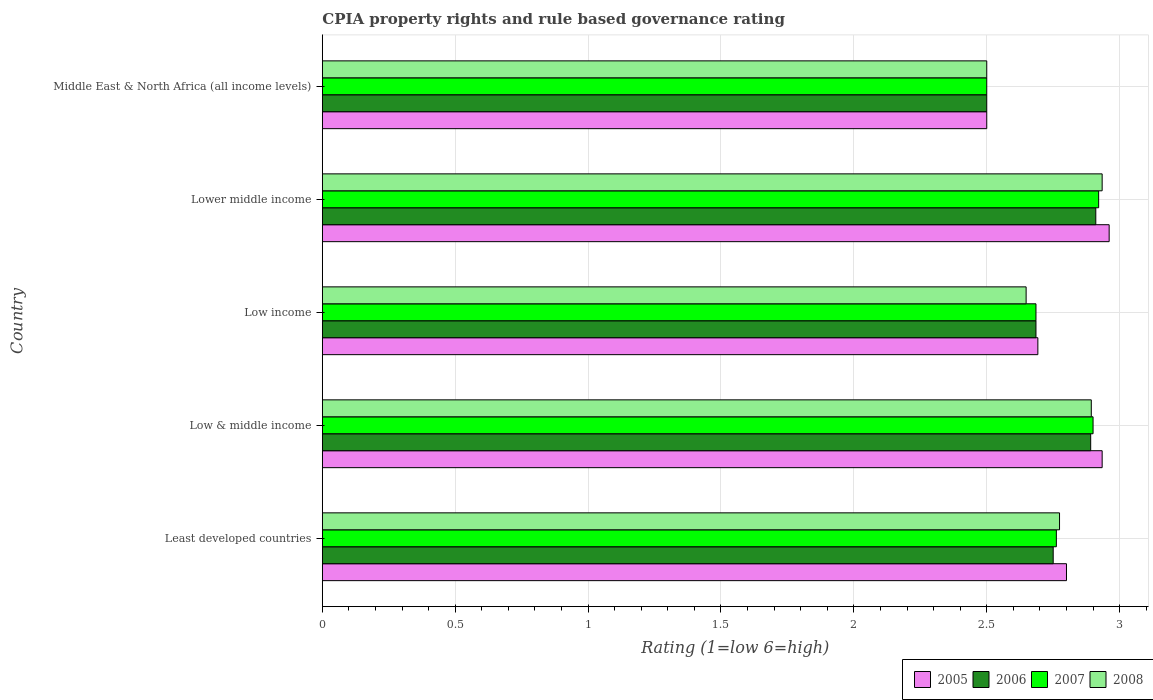How many different coloured bars are there?
Offer a terse response. 4. Are the number of bars per tick equal to the number of legend labels?
Make the answer very short. Yes. How many bars are there on the 2nd tick from the bottom?
Offer a terse response. 4. What is the CPIA rating in 2007 in Low income?
Your answer should be very brief. 2.69. Across all countries, what is the maximum CPIA rating in 2006?
Ensure brevity in your answer.  2.91. In which country was the CPIA rating in 2007 maximum?
Your answer should be compact. Lower middle income. In which country was the CPIA rating in 2006 minimum?
Your answer should be very brief. Middle East & North Africa (all income levels). What is the total CPIA rating in 2008 in the graph?
Provide a succinct answer. 13.75. What is the difference between the CPIA rating in 2008 in Low income and that in Middle East & North Africa (all income levels)?
Keep it short and to the point. 0.15. What is the difference between the CPIA rating in 2005 in Lower middle income and the CPIA rating in 2008 in Middle East & North Africa (all income levels)?
Provide a short and direct response. 0.46. What is the average CPIA rating in 2005 per country?
Offer a terse response. 2.78. What is the ratio of the CPIA rating in 2005 in Least developed countries to that in Lower middle income?
Your answer should be compact. 0.95. Is the CPIA rating in 2008 in Least developed countries less than that in Low income?
Offer a very short reply. No. Is the difference between the CPIA rating in 2007 in Least developed countries and Middle East & North Africa (all income levels) greater than the difference between the CPIA rating in 2008 in Least developed countries and Middle East & North Africa (all income levels)?
Give a very brief answer. No. What is the difference between the highest and the second highest CPIA rating in 2005?
Provide a short and direct response. 0.03. What is the difference between the highest and the lowest CPIA rating in 2007?
Ensure brevity in your answer.  0.42. In how many countries, is the CPIA rating in 2006 greater than the average CPIA rating in 2006 taken over all countries?
Keep it short and to the point. 3. Is it the case that in every country, the sum of the CPIA rating in 2008 and CPIA rating in 2005 is greater than the sum of CPIA rating in 2006 and CPIA rating in 2007?
Offer a very short reply. No. What does the 3rd bar from the bottom in Lower middle income represents?
Ensure brevity in your answer.  2007. Are all the bars in the graph horizontal?
Your answer should be very brief. Yes. How many countries are there in the graph?
Your answer should be compact. 5. What is the difference between two consecutive major ticks on the X-axis?
Provide a short and direct response. 0.5. Are the values on the major ticks of X-axis written in scientific E-notation?
Offer a very short reply. No. Where does the legend appear in the graph?
Your answer should be very brief. Bottom right. How many legend labels are there?
Offer a very short reply. 4. What is the title of the graph?
Make the answer very short. CPIA property rights and rule based governance rating. Does "1969" appear as one of the legend labels in the graph?
Your answer should be compact. No. What is the label or title of the Y-axis?
Offer a terse response. Country. What is the Rating (1=low 6=high) in 2005 in Least developed countries?
Offer a terse response. 2.8. What is the Rating (1=low 6=high) in 2006 in Least developed countries?
Provide a short and direct response. 2.75. What is the Rating (1=low 6=high) in 2007 in Least developed countries?
Offer a very short reply. 2.76. What is the Rating (1=low 6=high) of 2008 in Least developed countries?
Provide a short and direct response. 2.77. What is the Rating (1=low 6=high) in 2005 in Low & middle income?
Give a very brief answer. 2.93. What is the Rating (1=low 6=high) of 2006 in Low & middle income?
Provide a short and direct response. 2.89. What is the Rating (1=low 6=high) of 2008 in Low & middle income?
Your answer should be very brief. 2.89. What is the Rating (1=low 6=high) of 2005 in Low income?
Give a very brief answer. 2.69. What is the Rating (1=low 6=high) in 2006 in Low income?
Keep it short and to the point. 2.69. What is the Rating (1=low 6=high) in 2007 in Low income?
Keep it short and to the point. 2.69. What is the Rating (1=low 6=high) in 2008 in Low income?
Your answer should be compact. 2.65. What is the Rating (1=low 6=high) in 2005 in Lower middle income?
Keep it short and to the point. 2.96. What is the Rating (1=low 6=high) in 2006 in Lower middle income?
Keep it short and to the point. 2.91. What is the Rating (1=low 6=high) of 2007 in Lower middle income?
Your answer should be compact. 2.92. What is the Rating (1=low 6=high) of 2008 in Lower middle income?
Offer a terse response. 2.93. What is the Rating (1=low 6=high) in 2005 in Middle East & North Africa (all income levels)?
Make the answer very short. 2.5. What is the Rating (1=low 6=high) of 2007 in Middle East & North Africa (all income levels)?
Give a very brief answer. 2.5. What is the Rating (1=low 6=high) in 2008 in Middle East & North Africa (all income levels)?
Offer a very short reply. 2.5. Across all countries, what is the maximum Rating (1=low 6=high) of 2005?
Ensure brevity in your answer.  2.96. Across all countries, what is the maximum Rating (1=low 6=high) of 2006?
Make the answer very short. 2.91. Across all countries, what is the maximum Rating (1=low 6=high) in 2007?
Provide a succinct answer. 2.92. Across all countries, what is the maximum Rating (1=low 6=high) of 2008?
Offer a very short reply. 2.93. Across all countries, what is the minimum Rating (1=low 6=high) in 2005?
Offer a very short reply. 2.5. Across all countries, what is the minimum Rating (1=low 6=high) in 2006?
Provide a succinct answer. 2.5. Across all countries, what is the minimum Rating (1=low 6=high) in 2008?
Your response must be concise. 2.5. What is the total Rating (1=low 6=high) in 2005 in the graph?
Offer a terse response. 13.89. What is the total Rating (1=low 6=high) of 2006 in the graph?
Make the answer very short. 13.74. What is the total Rating (1=low 6=high) in 2007 in the graph?
Provide a short and direct response. 13.77. What is the total Rating (1=low 6=high) of 2008 in the graph?
Your response must be concise. 13.75. What is the difference between the Rating (1=low 6=high) in 2005 in Least developed countries and that in Low & middle income?
Make the answer very short. -0.13. What is the difference between the Rating (1=low 6=high) of 2006 in Least developed countries and that in Low & middle income?
Give a very brief answer. -0.14. What is the difference between the Rating (1=low 6=high) in 2007 in Least developed countries and that in Low & middle income?
Provide a short and direct response. -0.14. What is the difference between the Rating (1=low 6=high) in 2008 in Least developed countries and that in Low & middle income?
Offer a very short reply. -0.12. What is the difference between the Rating (1=low 6=high) of 2005 in Least developed countries and that in Low income?
Make the answer very short. 0.11. What is the difference between the Rating (1=low 6=high) in 2006 in Least developed countries and that in Low income?
Provide a succinct answer. 0.06. What is the difference between the Rating (1=low 6=high) in 2007 in Least developed countries and that in Low income?
Give a very brief answer. 0.08. What is the difference between the Rating (1=low 6=high) in 2008 in Least developed countries and that in Low income?
Ensure brevity in your answer.  0.13. What is the difference between the Rating (1=low 6=high) in 2005 in Least developed countries and that in Lower middle income?
Give a very brief answer. -0.16. What is the difference between the Rating (1=low 6=high) in 2006 in Least developed countries and that in Lower middle income?
Make the answer very short. -0.16. What is the difference between the Rating (1=low 6=high) of 2007 in Least developed countries and that in Lower middle income?
Give a very brief answer. -0.16. What is the difference between the Rating (1=low 6=high) in 2008 in Least developed countries and that in Lower middle income?
Offer a terse response. -0.16. What is the difference between the Rating (1=low 6=high) in 2006 in Least developed countries and that in Middle East & North Africa (all income levels)?
Your answer should be very brief. 0.25. What is the difference between the Rating (1=low 6=high) of 2007 in Least developed countries and that in Middle East & North Africa (all income levels)?
Your response must be concise. 0.26. What is the difference between the Rating (1=low 6=high) in 2008 in Least developed countries and that in Middle East & North Africa (all income levels)?
Make the answer very short. 0.27. What is the difference between the Rating (1=low 6=high) of 2005 in Low & middle income and that in Low income?
Offer a terse response. 0.24. What is the difference between the Rating (1=low 6=high) of 2006 in Low & middle income and that in Low income?
Your response must be concise. 0.21. What is the difference between the Rating (1=low 6=high) in 2007 in Low & middle income and that in Low income?
Give a very brief answer. 0.21. What is the difference between the Rating (1=low 6=high) in 2008 in Low & middle income and that in Low income?
Offer a very short reply. 0.25. What is the difference between the Rating (1=low 6=high) of 2005 in Low & middle income and that in Lower middle income?
Give a very brief answer. -0.03. What is the difference between the Rating (1=low 6=high) in 2006 in Low & middle income and that in Lower middle income?
Your answer should be very brief. -0.02. What is the difference between the Rating (1=low 6=high) in 2007 in Low & middle income and that in Lower middle income?
Your response must be concise. -0.02. What is the difference between the Rating (1=low 6=high) of 2008 in Low & middle income and that in Lower middle income?
Provide a succinct answer. -0.04. What is the difference between the Rating (1=low 6=high) in 2005 in Low & middle income and that in Middle East & North Africa (all income levels)?
Keep it short and to the point. 0.43. What is the difference between the Rating (1=low 6=high) in 2006 in Low & middle income and that in Middle East & North Africa (all income levels)?
Make the answer very short. 0.39. What is the difference between the Rating (1=low 6=high) in 2007 in Low & middle income and that in Middle East & North Africa (all income levels)?
Keep it short and to the point. 0.4. What is the difference between the Rating (1=low 6=high) in 2008 in Low & middle income and that in Middle East & North Africa (all income levels)?
Offer a terse response. 0.39. What is the difference between the Rating (1=low 6=high) in 2005 in Low income and that in Lower middle income?
Provide a succinct answer. -0.27. What is the difference between the Rating (1=low 6=high) of 2006 in Low income and that in Lower middle income?
Offer a very short reply. -0.23. What is the difference between the Rating (1=low 6=high) of 2007 in Low income and that in Lower middle income?
Your response must be concise. -0.24. What is the difference between the Rating (1=low 6=high) of 2008 in Low income and that in Lower middle income?
Give a very brief answer. -0.29. What is the difference between the Rating (1=low 6=high) of 2005 in Low income and that in Middle East & North Africa (all income levels)?
Make the answer very short. 0.19. What is the difference between the Rating (1=low 6=high) in 2006 in Low income and that in Middle East & North Africa (all income levels)?
Offer a terse response. 0.19. What is the difference between the Rating (1=low 6=high) of 2007 in Low income and that in Middle East & North Africa (all income levels)?
Provide a short and direct response. 0.19. What is the difference between the Rating (1=low 6=high) of 2008 in Low income and that in Middle East & North Africa (all income levels)?
Give a very brief answer. 0.15. What is the difference between the Rating (1=low 6=high) of 2005 in Lower middle income and that in Middle East & North Africa (all income levels)?
Ensure brevity in your answer.  0.46. What is the difference between the Rating (1=low 6=high) in 2006 in Lower middle income and that in Middle East & North Africa (all income levels)?
Offer a very short reply. 0.41. What is the difference between the Rating (1=low 6=high) in 2007 in Lower middle income and that in Middle East & North Africa (all income levels)?
Keep it short and to the point. 0.42. What is the difference between the Rating (1=low 6=high) in 2008 in Lower middle income and that in Middle East & North Africa (all income levels)?
Make the answer very short. 0.43. What is the difference between the Rating (1=low 6=high) of 2005 in Least developed countries and the Rating (1=low 6=high) of 2006 in Low & middle income?
Provide a short and direct response. -0.09. What is the difference between the Rating (1=low 6=high) of 2005 in Least developed countries and the Rating (1=low 6=high) of 2007 in Low & middle income?
Ensure brevity in your answer.  -0.1. What is the difference between the Rating (1=low 6=high) in 2005 in Least developed countries and the Rating (1=low 6=high) in 2008 in Low & middle income?
Your response must be concise. -0.09. What is the difference between the Rating (1=low 6=high) of 2006 in Least developed countries and the Rating (1=low 6=high) of 2008 in Low & middle income?
Provide a short and direct response. -0.14. What is the difference between the Rating (1=low 6=high) in 2007 in Least developed countries and the Rating (1=low 6=high) in 2008 in Low & middle income?
Give a very brief answer. -0.13. What is the difference between the Rating (1=low 6=high) of 2005 in Least developed countries and the Rating (1=low 6=high) of 2006 in Low income?
Your response must be concise. 0.11. What is the difference between the Rating (1=low 6=high) of 2005 in Least developed countries and the Rating (1=low 6=high) of 2007 in Low income?
Offer a terse response. 0.11. What is the difference between the Rating (1=low 6=high) in 2005 in Least developed countries and the Rating (1=low 6=high) in 2008 in Low income?
Your answer should be compact. 0.15. What is the difference between the Rating (1=low 6=high) in 2006 in Least developed countries and the Rating (1=low 6=high) in 2007 in Low income?
Your answer should be very brief. 0.06. What is the difference between the Rating (1=low 6=high) in 2006 in Least developed countries and the Rating (1=low 6=high) in 2008 in Low income?
Offer a terse response. 0.1. What is the difference between the Rating (1=low 6=high) of 2007 in Least developed countries and the Rating (1=low 6=high) of 2008 in Low income?
Your response must be concise. 0.11. What is the difference between the Rating (1=low 6=high) in 2005 in Least developed countries and the Rating (1=low 6=high) in 2006 in Lower middle income?
Ensure brevity in your answer.  -0.11. What is the difference between the Rating (1=low 6=high) in 2005 in Least developed countries and the Rating (1=low 6=high) in 2007 in Lower middle income?
Your answer should be very brief. -0.12. What is the difference between the Rating (1=low 6=high) in 2005 in Least developed countries and the Rating (1=low 6=high) in 2008 in Lower middle income?
Ensure brevity in your answer.  -0.13. What is the difference between the Rating (1=low 6=high) in 2006 in Least developed countries and the Rating (1=low 6=high) in 2007 in Lower middle income?
Give a very brief answer. -0.17. What is the difference between the Rating (1=low 6=high) of 2006 in Least developed countries and the Rating (1=low 6=high) of 2008 in Lower middle income?
Keep it short and to the point. -0.18. What is the difference between the Rating (1=low 6=high) in 2007 in Least developed countries and the Rating (1=low 6=high) in 2008 in Lower middle income?
Your answer should be compact. -0.17. What is the difference between the Rating (1=low 6=high) of 2006 in Least developed countries and the Rating (1=low 6=high) of 2008 in Middle East & North Africa (all income levels)?
Offer a terse response. 0.25. What is the difference between the Rating (1=low 6=high) in 2007 in Least developed countries and the Rating (1=low 6=high) in 2008 in Middle East & North Africa (all income levels)?
Keep it short and to the point. 0.26. What is the difference between the Rating (1=low 6=high) of 2005 in Low & middle income and the Rating (1=low 6=high) of 2006 in Low income?
Give a very brief answer. 0.25. What is the difference between the Rating (1=low 6=high) in 2005 in Low & middle income and the Rating (1=low 6=high) in 2007 in Low income?
Your answer should be very brief. 0.25. What is the difference between the Rating (1=low 6=high) in 2005 in Low & middle income and the Rating (1=low 6=high) in 2008 in Low income?
Keep it short and to the point. 0.29. What is the difference between the Rating (1=low 6=high) in 2006 in Low & middle income and the Rating (1=low 6=high) in 2007 in Low income?
Provide a succinct answer. 0.21. What is the difference between the Rating (1=low 6=high) in 2006 in Low & middle income and the Rating (1=low 6=high) in 2008 in Low income?
Ensure brevity in your answer.  0.24. What is the difference between the Rating (1=low 6=high) in 2007 in Low & middle income and the Rating (1=low 6=high) in 2008 in Low income?
Ensure brevity in your answer.  0.25. What is the difference between the Rating (1=low 6=high) of 2005 in Low & middle income and the Rating (1=low 6=high) of 2006 in Lower middle income?
Provide a short and direct response. 0.02. What is the difference between the Rating (1=low 6=high) in 2005 in Low & middle income and the Rating (1=low 6=high) in 2007 in Lower middle income?
Keep it short and to the point. 0.01. What is the difference between the Rating (1=low 6=high) in 2005 in Low & middle income and the Rating (1=low 6=high) in 2008 in Lower middle income?
Your response must be concise. 0. What is the difference between the Rating (1=low 6=high) of 2006 in Low & middle income and the Rating (1=low 6=high) of 2007 in Lower middle income?
Keep it short and to the point. -0.03. What is the difference between the Rating (1=low 6=high) of 2006 in Low & middle income and the Rating (1=low 6=high) of 2008 in Lower middle income?
Offer a very short reply. -0.04. What is the difference between the Rating (1=low 6=high) in 2007 in Low & middle income and the Rating (1=low 6=high) in 2008 in Lower middle income?
Give a very brief answer. -0.03. What is the difference between the Rating (1=low 6=high) of 2005 in Low & middle income and the Rating (1=low 6=high) of 2006 in Middle East & North Africa (all income levels)?
Keep it short and to the point. 0.43. What is the difference between the Rating (1=low 6=high) of 2005 in Low & middle income and the Rating (1=low 6=high) of 2007 in Middle East & North Africa (all income levels)?
Your answer should be compact. 0.43. What is the difference between the Rating (1=low 6=high) of 2005 in Low & middle income and the Rating (1=low 6=high) of 2008 in Middle East & North Africa (all income levels)?
Make the answer very short. 0.43. What is the difference between the Rating (1=low 6=high) of 2006 in Low & middle income and the Rating (1=low 6=high) of 2007 in Middle East & North Africa (all income levels)?
Ensure brevity in your answer.  0.39. What is the difference between the Rating (1=low 6=high) of 2006 in Low & middle income and the Rating (1=low 6=high) of 2008 in Middle East & North Africa (all income levels)?
Provide a succinct answer. 0.39. What is the difference between the Rating (1=low 6=high) of 2007 in Low & middle income and the Rating (1=low 6=high) of 2008 in Middle East & North Africa (all income levels)?
Make the answer very short. 0.4. What is the difference between the Rating (1=low 6=high) of 2005 in Low income and the Rating (1=low 6=high) of 2006 in Lower middle income?
Provide a short and direct response. -0.22. What is the difference between the Rating (1=low 6=high) in 2005 in Low income and the Rating (1=low 6=high) in 2007 in Lower middle income?
Give a very brief answer. -0.23. What is the difference between the Rating (1=low 6=high) of 2005 in Low income and the Rating (1=low 6=high) of 2008 in Lower middle income?
Your response must be concise. -0.24. What is the difference between the Rating (1=low 6=high) in 2006 in Low income and the Rating (1=low 6=high) in 2007 in Lower middle income?
Provide a short and direct response. -0.24. What is the difference between the Rating (1=low 6=high) of 2006 in Low income and the Rating (1=low 6=high) of 2008 in Lower middle income?
Provide a short and direct response. -0.25. What is the difference between the Rating (1=low 6=high) in 2007 in Low income and the Rating (1=low 6=high) in 2008 in Lower middle income?
Give a very brief answer. -0.25. What is the difference between the Rating (1=low 6=high) in 2005 in Low income and the Rating (1=low 6=high) in 2006 in Middle East & North Africa (all income levels)?
Provide a short and direct response. 0.19. What is the difference between the Rating (1=low 6=high) of 2005 in Low income and the Rating (1=low 6=high) of 2007 in Middle East & North Africa (all income levels)?
Make the answer very short. 0.19. What is the difference between the Rating (1=low 6=high) in 2005 in Low income and the Rating (1=low 6=high) in 2008 in Middle East & North Africa (all income levels)?
Your response must be concise. 0.19. What is the difference between the Rating (1=low 6=high) of 2006 in Low income and the Rating (1=low 6=high) of 2007 in Middle East & North Africa (all income levels)?
Offer a very short reply. 0.19. What is the difference between the Rating (1=low 6=high) of 2006 in Low income and the Rating (1=low 6=high) of 2008 in Middle East & North Africa (all income levels)?
Offer a very short reply. 0.19. What is the difference between the Rating (1=low 6=high) in 2007 in Low income and the Rating (1=low 6=high) in 2008 in Middle East & North Africa (all income levels)?
Your answer should be very brief. 0.19. What is the difference between the Rating (1=low 6=high) in 2005 in Lower middle income and the Rating (1=low 6=high) in 2006 in Middle East & North Africa (all income levels)?
Your answer should be compact. 0.46. What is the difference between the Rating (1=low 6=high) of 2005 in Lower middle income and the Rating (1=low 6=high) of 2007 in Middle East & North Africa (all income levels)?
Your answer should be compact. 0.46. What is the difference between the Rating (1=low 6=high) of 2005 in Lower middle income and the Rating (1=low 6=high) of 2008 in Middle East & North Africa (all income levels)?
Your response must be concise. 0.46. What is the difference between the Rating (1=low 6=high) in 2006 in Lower middle income and the Rating (1=low 6=high) in 2007 in Middle East & North Africa (all income levels)?
Your answer should be compact. 0.41. What is the difference between the Rating (1=low 6=high) of 2006 in Lower middle income and the Rating (1=low 6=high) of 2008 in Middle East & North Africa (all income levels)?
Keep it short and to the point. 0.41. What is the difference between the Rating (1=low 6=high) of 2007 in Lower middle income and the Rating (1=low 6=high) of 2008 in Middle East & North Africa (all income levels)?
Provide a short and direct response. 0.42. What is the average Rating (1=low 6=high) of 2005 per country?
Your answer should be compact. 2.78. What is the average Rating (1=low 6=high) of 2006 per country?
Offer a very short reply. 2.75. What is the average Rating (1=low 6=high) of 2007 per country?
Provide a short and direct response. 2.75. What is the average Rating (1=low 6=high) in 2008 per country?
Make the answer very short. 2.75. What is the difference between the Rating (1=low 6=high) of 2005 and Rating (1=low 6=high) of 2006 in Least developed countries?
Offer a very short reply. 0.05. What is the difference between the Rating (1=low 6=high) of 2005 and Rating (1=low 6=high) of 2007 in Least developed countries?
Keep it short and to the point. 0.04. What is the difference between the Rating (1=low 6=high) in 2005 and Rating (1=low 6=high) in 2008 in Least developed countries?
Keep it short and to the point. 0.03. What is the difference between the Rating (1=low 6=high) in 2006 and Rating (1=low 6=high) in 2007 in Least developed countries?
Your response must be concise. -0.01. What is the difference between the Rating (1=low 6=high) in 2006 and Rating (1=low 6=high) in 2008 in Least developed countries?
Provide a succinct answer. -0.02. What is the difference between the Rating (1=low 6=high) in 2007 and Rating (1=low 6=high) in 2008 in Least developed countries?
Make the answer very short. -0.01. What is the difference between the Rating (1=low 6=high) in 2005 and Rating (1=low 6=high) in 2006 in Low & middle income?
Provide a succinct answer. 0.04. What is the difference between the Rating (1=low 6=high) of 2005 and Rating (1=low 6=high) of 2007 in Low & middle income?
Offer a very short reply. 0.03. What is the difference between the Rating (1=low 6=high) in 2005 and Rating (1=low 6=high) in 2008 in Low & middle income?
Your answer should be very brief. 0.04. What is the difference between the Rating (1=low 6=high) in 2006 and Rating (1=low 6=high) in 2007 in Low & middle income?
Offer a terse response. -0.01. What is the difference between the Rating (1=low 6=high) in 2006 and Rating (1=low 6=high) in 2008 in Low & middle income?
Your answer should be very brief. -0. What is the difference between the Rating (1=low 6=high) of 2007 and Rating (1=low 6=high) of 2008 in Low & middle income?
Ensure brevity in your answer.  0.01. What is the difference between the Rating (1=low 6=high) of 2005 and Rating (1=low 6=high) of 2006 in Low income?
Your answer should be compact. 0.01. What is the difference between the Rating (1=low 6=high) in 2005 and Rating (1=low 6=high) in 2007 in Low income?
Your answer should be very brief. 0.01. What is the difference between the Rating (1=low 6=high) in 2005 and Rating (1=low 6=high) in 2008 in Low income?
Your answer should be very brief. 0.04. What is the difference between the Rating (1=low 6=high) in 2006 and Rating (1=low 6=high) in 2007 in Low income?
Your response must be concise. 0. What is the difference between the Rating (1=low 6=high) in 2006 and Rating (1=low 6=high) in 2008 in Low income?
Give a very brief answer. 0.04. What is the difference between the Rating (1=low 6=high) of 2007 and Rating (1=low 6=high) of 2008 in Low income?
Keep it short and to the point. 0.04. What is the difference between the Rating (1=low 6=high) of 2005 and Rating (1=low 6=high) of 2006 in Lower middle income?
Offer a very short reply. 0.05. What is the difference between the Rating (1=low 6=high) in 2005 and Rating (1=low 6=high) in 2007 in Lower middle income?
Your response must be concise. 0.04. What is the difference between the Rating (1=low 6=high) of 2005 and Rating (1=low 6=high) of 2008 in Lower middle income?
Offer a very short reply. 0.03. What is the difference between the Rating (1=low 6=high) of 2006 and Rating (1=low 6=high) of 2007 in Lower middle income?
Your answer should be very brief. -0.01. What is the difference between the Rating (1=low 6=high) of 2006 and Rating (1=low 6=high) of 2008 in Lower middle income?
Provide a succinct answer. -0.02. What is the difference between the Rating (1=low 6=high) of 2007 and Rating (1=low 6=high) of 2008 in Lower middle income?
Your answer should be compact. -0.01. What is the difference between the Rating (1=low 6=high) in 2006 and Rating (1=low 6=high) in 2007 in Middle East & North Africa (all income levels)?
Your answer should be very brief. 0. What is the difference between the Rating (1=low 6=high) in 2006 and Rating (1=low 6=high) in 2008 in Middle East & North Africa (all income levels)?
Make the answer very short. 0. What is the difference between the Rating (1=low 6=high) in 2007 and Rating (1=low 6=high) in 2008 in Middle East & North Africa (all income levels)?
Offer a terse response. 0. What is the ratio of the Rating (1=low 6=high) in 2005 in Least developed countries to that in Low & middle income?
Your answer should be compact. 0.95. What is the ratio of the Rating (1=low 6=high) of 2006 in Least developed countries to that in Low & middle income?
Keep it short and to the point. 0.95. What is the ratio of the Rating (1=low 6=high) of 2007 in Least developed countries to that in Low & middle income?
Make the answer very short. 0.95. What is the ratio of the Rating (1=low 6=high) in 2008 in Least developed countries to that in Low & middle income?
Provide a succinct answer. 0.96. What is the ratio of the Rating (1=low 6=high) of 2006 in Least developed countries to that in Low income?
Your response must be concise. 1.02. What is the ratio of the Rating (1=low 6=high) in 2007 in Least developed countries to that in Low income?
Make the answer very short. 1.03. What is the ratio of the Rating (1=low 6=high) of 2008 in Least developed countries to that in Low income?
Keep it short and to the point. 1.05. What is the ratio of the Rating (1=low 6=high) of 2005 in Least developed countries to that in Lower middle income?
Ensure brevity in your answer.  0.95. What is the ratio of the Rating (1=low 6=high) of 2006 in Least developed countries to that in Lower middle income?
Ensure brevity in your answer.  0.94. What is the ratio of the Rating (1=low 6=high) in 2007 in Least developed countries to that in Lower middle income?
Your answer should be compact. 0.95. What is the ratio of the Rating (1=low 6=high) in 2008 in Least developed countries to that in Lower middle income?
Make the answer very short. 0.95. What is the ratio of the Rating (1=low 6=high) in 2005 in Least developed countries to that in Middle East & North Africa (all income levels)?
Your answer should be very brief. 1.12. What is the ratio of the Rating (1=low 6=high) of 2006 in Least developed countries to that in Middle East & North Africa (all income levels)?
Offer a terse response. 1.1. What is the ratio of the Rating (1=low 6=high) of 2007 in Least developed countries to that in Middle East & North Africa (all income levels)?
Provide a short and direct response. 1.1. What is the ratio of the Rating (1=low 6=high) in 2008 in Least developed countries to that in Middle East & North Africa (all income levels)?
Your answer should be compact. 1.11. What is the ratio of the Rating (1=low 6=high) in 2005 in Low & middle income to that in Low income?
Your response must be concise. 1.09. What is the ratio of the Rating (1=low 6=high) in 2006 in Low & middle income to that in Low income?
Your answer should be very brief. 1.08. What is the ratio of the Rating (1=low 6=high) of 2008 in Low & middle income to that in Low income?
Provide a succinct answer. 1.09. What is the ratio of the Rating (1=low 6=high) of 2008 in Low & middle income to that in Lower middle income?
Give a very brief answer. 0.99. What is the ratio of the Rating (1=low 6=high) in 2005 in Low & middle income to that in Middle East & North Africa (all income levels)?
Make the answer very short. 1.17. What is the ratio of the Rating (1=low 6=high) in 2006 in Low & middle income to that in Middle East & North Africa (all income levels)?
Offer a very short reply. 1.16. What is the ratio of the Rating (1=low 6=high) in 2007 in Low & middle income to that in Middle East & North Africa (all income levels)?
Keep it short and to the point. 1.16. What is the ratio of the Rating (1=low 6=high) of 2008 in Low & middle income to that in Middle East & North Africa (all income levels)?
Ensure brevity in your answer.  1.16. What is the ratio of the Rating (1=low 6=high) of 2005 in Low income to that in Lower middle income?
Your answer should be compact. 0.91. What is the ratio of the Rating (1=low 6=high) in 2006 in Low income to that in Lower middle income?
Your answer should be compact. 0.92. What is the ratio of the Rating (1=low 6=high) in 2007 in Low income to that in Lower middle income?
Provide a short and direct response. 0.92. What is the ratio of the Rating (1=low 6=high) in 2008 in Low income to that in Lower middle income?
Ensure brevity in your answer.  0.9. What is the ratio of the Rating (1=low 6=high) in 2005 in Low income to that in Middle East & North Africa (all income levels)?
Offer a terse response. 1.08. What is the ratio of the Rating (1=low 6=high) of 2006 in Low income to that in Middle East & North Africa (all income levels)?
Make the answer very short. 1.07. What is the ratio of the Rating (1=low 6=high) in 2007 in Low income to that in Middle East & North Africa (all income levels)?
Ensure brevity in your answer.  1.07. What is the ratio of the Rating (1=low 6=high) of 2008 in Low income to that in Middle East & North Africa (all income levels)?
Make the answer very short. 1.06. What is the ratio of the Rating (1=low 6=high) in 2005 in Lower middle income to that in Middle East & North Africa (all income levels)?
Make the answer very short. 1.18. What is the ratio of the Rating (1=low 6=high) in 2006 in Lower middle income to that in Middle East & North Africa (all income levels)?
Your answer should be compact. 1.16. What is the ratio of the Rating (1=low 6=high) of 2007 in Lower middle income to that in Middle East & North Africa (all income levels)?
Your answer should be very brief. 1.17. What is the ratio of the Rating (1=low 6=high) in 2008 in Lower middle income to that in Middle East & North Africa (all income levels)?
Offer a very short reply. 1.17. What is the difference between the highest and the second highest Rating (1=low 6=high) of 2005?
Make the answer very short. 0.03. What is the difference between the highest and the second highest Rating (1=low 6=high) in 2006?
Your response must be concise. 0.02. What is the difference between the highest and the second highest Rating (1=low 6=high) of 2007?
Give a very brief answer. 0.02. What is the difference between the highest and the second highest Rating (1=low 6=high) in 2008?
Offer a terse response. 0.04. What is the difference between the highest and the lowest Rating (1=low 6=high) of 2005?
Ensure brevity in your answer.  0.46. What is the difference between the highest and the lowest Rating (1=low 6=high) in 2006?
Offer a terse response. 0.41. What is the difference between the highest and the lowest Rating (1=low 6=high) in 2007?
Keep it short and to the point. 0.42. What is the difference between the highest and the lowest Rating (1=low 6=high) of 2008?
Offer a very short reply. 0.43. 